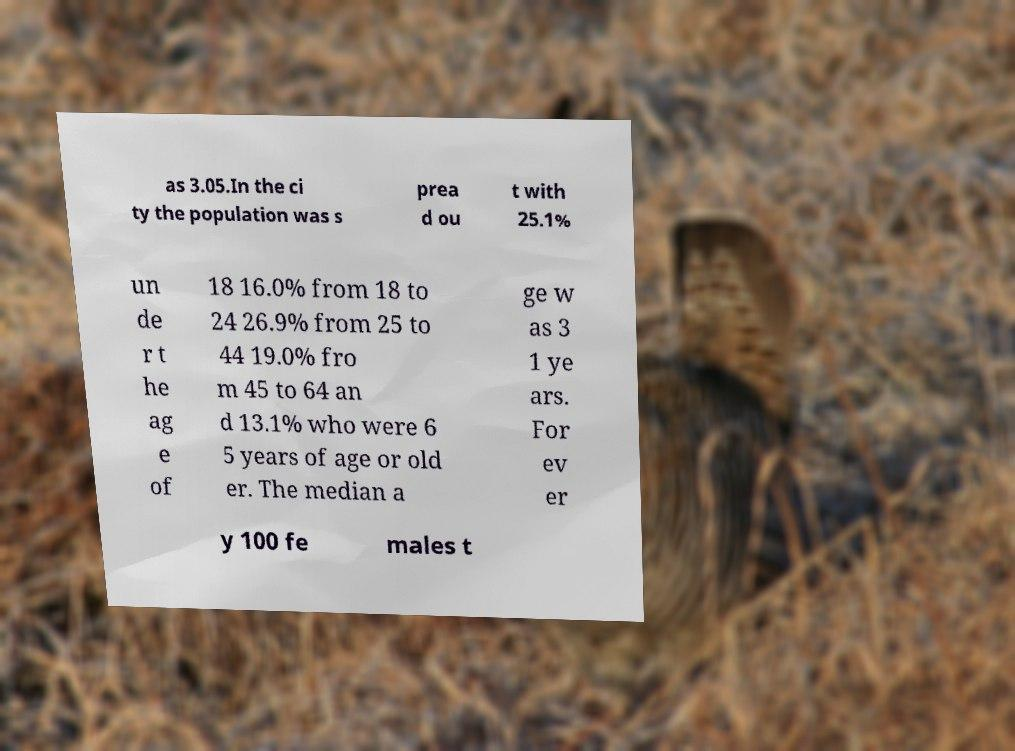What messages or text are displayed in this image? I need them in a readable, typed format. as 3.05.In the ci ty the population was s prea d ou t with 25.1% un de r t he ag e of 18 16.0% from 18 to 24 26.9% from 25 to 44 19.0% fro m 45 to 64 an d 13.1% who were 6 5 years of age or old er. The median a ge w as 3 1 ye ars. For ev er y 100 fe males t 